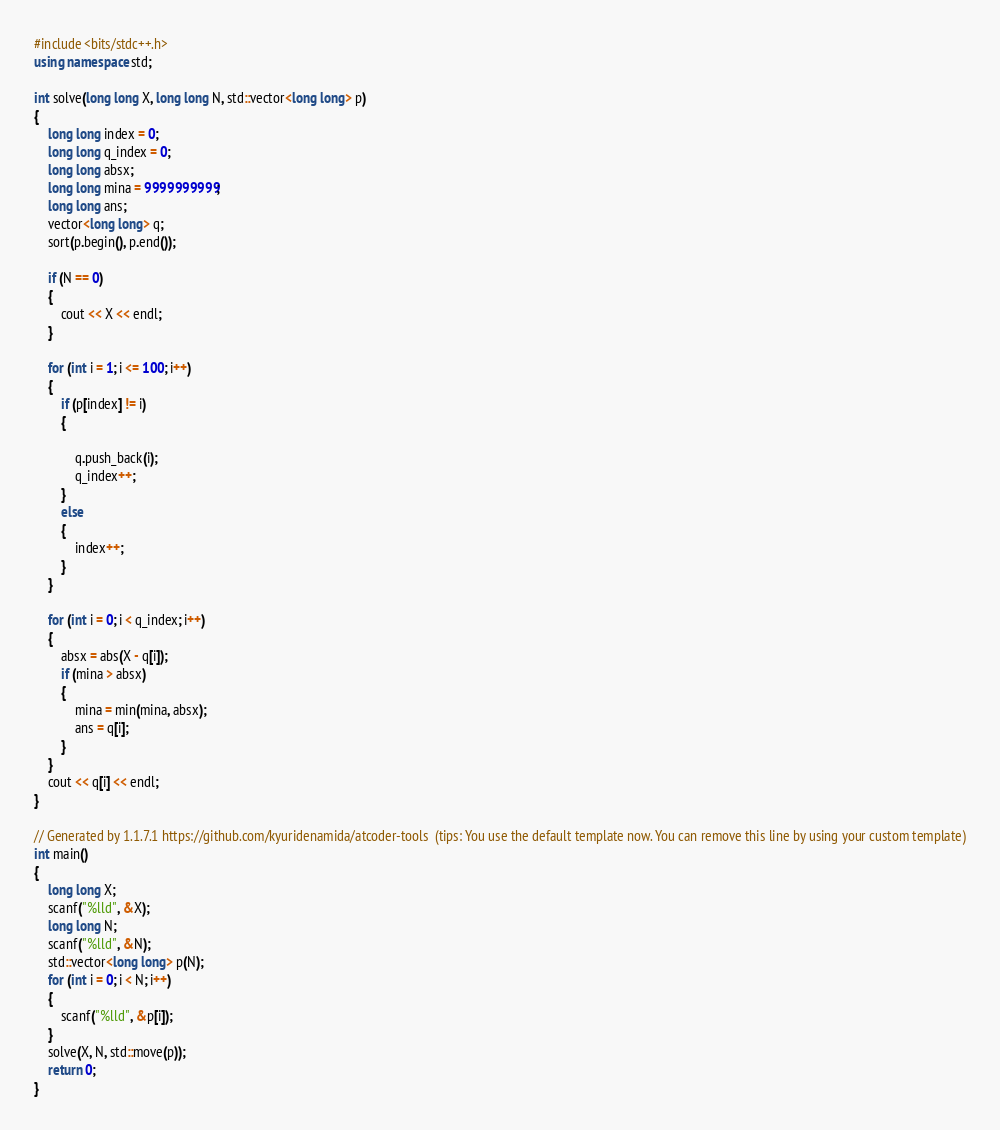<code> <loc_0><loc_0><loc_500><loc_500><_C++_>#include <bits/stdc++.h>
using namespace std;

int solve(long long X, long long N, std::vector<long long> p)
{
    long long index = 0;
    long long q_index = 0;
    long long absx;
    long long mina = 9999999999;
    long long ans;
    vector<long long> q;
    sort(p.begin(), p.end());

    if (N == 0)
    {
        cout << X << endl;
    }

    for (int i = 1; i <= 100; i++)
    {
        if (p[index] != i)
        {

            q.push_back(i);
            q_index++;
        }
        else
        {
            index++;
        }
    }

    for (int i = 0; i < q_index; i++)
    {
        absx = abs(X - q[i]);
        if (mina > absx)
        {
            mina = min(mina, absx);
            ans = q[i];
        }
    }
    cout << q[i] << endl;
}

// Generated by 1.1.7.1 https://github.com/kyuridenamida/atcoder-tools  (tips: You use the default template now. You can remove this line by using your custom template)
int main()
{
    long long X;
    scanf("%lld", &X);
    long long N;
    scanf("%lld", &N);
    std::vector<long long> p(N);
    for (int i = 0; i < N; i++)
    {
        scanf("%lld", &p[i]);
    }
    solve(X, N, std::move(p));
    return 0;
}
</code> 